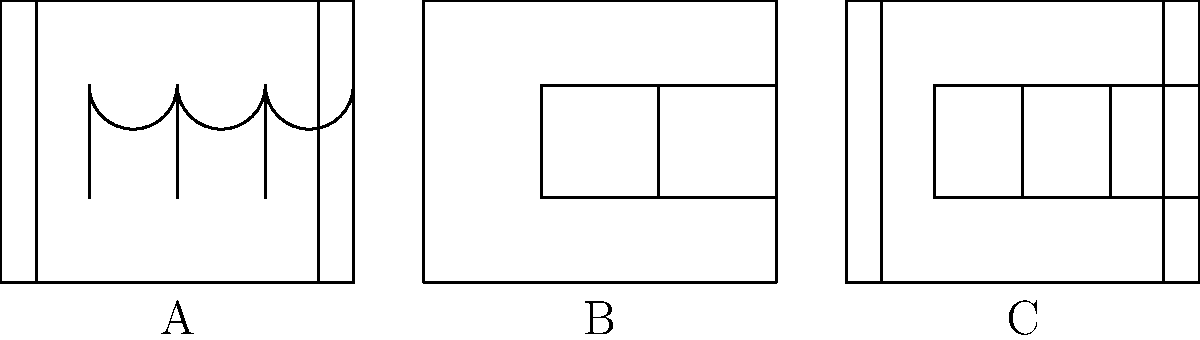Which of the facade sketches (A, B, or C) most closely represents the Neoclassical architectural style? To identify the Neoclassical architectural style, we need to consider its key features:

1. Symmetry and proportion: Neoclassical buildings are typically symmetrical.
2. Columns: Often feature prominent columns, especially in the front.
3. Simple geometric forms: Clean lines and shapes.
4. Rectangular windows: Usually evenly spaced and rectangular.

Let's analyze each facade:

A: This facade has arched windows and columns. While columns are a feature of Neoclassical architecture, arched windows are more characteristic of Romanesque or Renaissance styles.

B: This facade is simple with rectangular windows, but lacks columns and appears less formal, which is atypical of Neoclassical architecture.

C: This facade demonstrates key Neoclassical features:
   - Symmetry with three evenly spaced windows
   - Prominent columns on both sides
   - Rectangular windows
   - Simple, clean geometric forms

Therefore, facade C most closely represents the Neoclassical architectural style.
Answer: C 